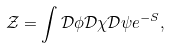<formula> <loc_0><loc_0><loc_500><loc_500>\mathcal { Z } = \int \mathcal { D } \phi \mathcal { D } \chi \mathcal { D } \psi e ^ { - S } ,</formula> 